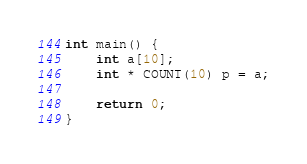Convert code to text. <code><loc_0><loc_0><loc_500><loc_500><_C_>int main() {
    int a[10];
    int * COUNT(10) p = a;

    return 0;
}
</code> 